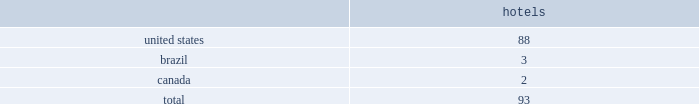Host hotels & resorts , inc. , host hotels & resorts , l.p. , and subsidiaries notes to consolidated financial statements 1 .
Summary of significant accounting policies description of business host hotels & resorts , inc .
Operates as a self-managed and self-administered real estate investment trust , or reit , with its operations conducted solely through host hotels & resorts , l.p .
Host hotels & resorts , l.p. , a delaware limited partnership , operates through an umbrella partnership structure , with host hotels & resorts , inc. , a maryland corporation , as its sole general partner .
In the notes to the consolidated financial statements , we use the terms 201cwe 201d or 201cour 201d to refer to host hotels & resorts , inc .
And host hotels & resorts , l.p .
Together , unless the context indicates otherwise .
We also use the term 201chost inc . 201d to refer specifically to host hotels & resorts , inc .
And the term 201chost l.p . 201d to refer specifically to host hotels & resorts , l.p .
In cases where it is important to distinguish between host inc .
And host l.p .
Host inc .
Holds approximately 99% ( 99 % ) of host l.p . 2019s partnership interests , or op units .
Consolidated portfolio as of december 31 , 2018 , the hotels in our consolidated portfolio are in the following countries: .
Basis of presentation and principles of consolidation the accompanying consolidated financial statements include the consolidated accounts of host inc. , host l.p .
And their subsidiaries and controlled affiliates , including joint ventures and partnerships .
We consolidate subsidiaries when we have the ability to control them .
For the majority of our hotel and real estate investments , we consider those control rights to be ( i ) approval or amendment of developments plans , ( ii ) financing decisions , ( iii ) approval or amendments of operating budgets , and ( iv ) investment strategy decisions .
We also evaluate our subsidiaries to determine if they are variable interest entities ( 201cvies 201d ) .
If a subsidiary is a vie , it is subject to the consolidation framework specifically for vies .
Typically , the entity that has the power to direct the activities that most significantly impact economic performance consolidates the vie .
We consider an entity to be a vie if equity investors own an interest therein that does not have the characteristics of a controlling financial interest or if such investors do not have sufficient equity at risk for the entity to finance its activities without additional subordinated financial support .
We review our subsidiaries and affiliates at least annually to determine if ( i ) they should be considered vies , and ( ii ) whether we should change our consolidation determination based on changes in the characteristics thereof .
Three partnerships are considered vie 2019s , as the general partner maintains control over the decisions that most significantly impact the partnerships .
The first vie is the operating partnership , host l.p. , which is consolidated by host inc. , of which host inc .
Is the general partner and holds 99% ( 99 % ) of the limited partner interests .
Host inc . 2019s sole significant asset is its investment in host l.p .
And substantially all of host inc . 2019s assets and liabilities represent assets and liabilities of host l.p .
All of host inc . 2019s debt is an obligation of host l.p .
And may be settled only with assets of host l.p .
The consolidated partnership that owns the houston airport marriott at george bush intercontinental , of which we are the general partner and hold 85% ( 85 % ) of the partnership interests , also is a vie .
The total assets of this vie at december 31 , 2018 are $ 48 million and consist primarily of cash and .
What percentage of hotel properties are not in the united states? 
Computations: ((2 + 3) / 93)
Answer: 0.05376. 